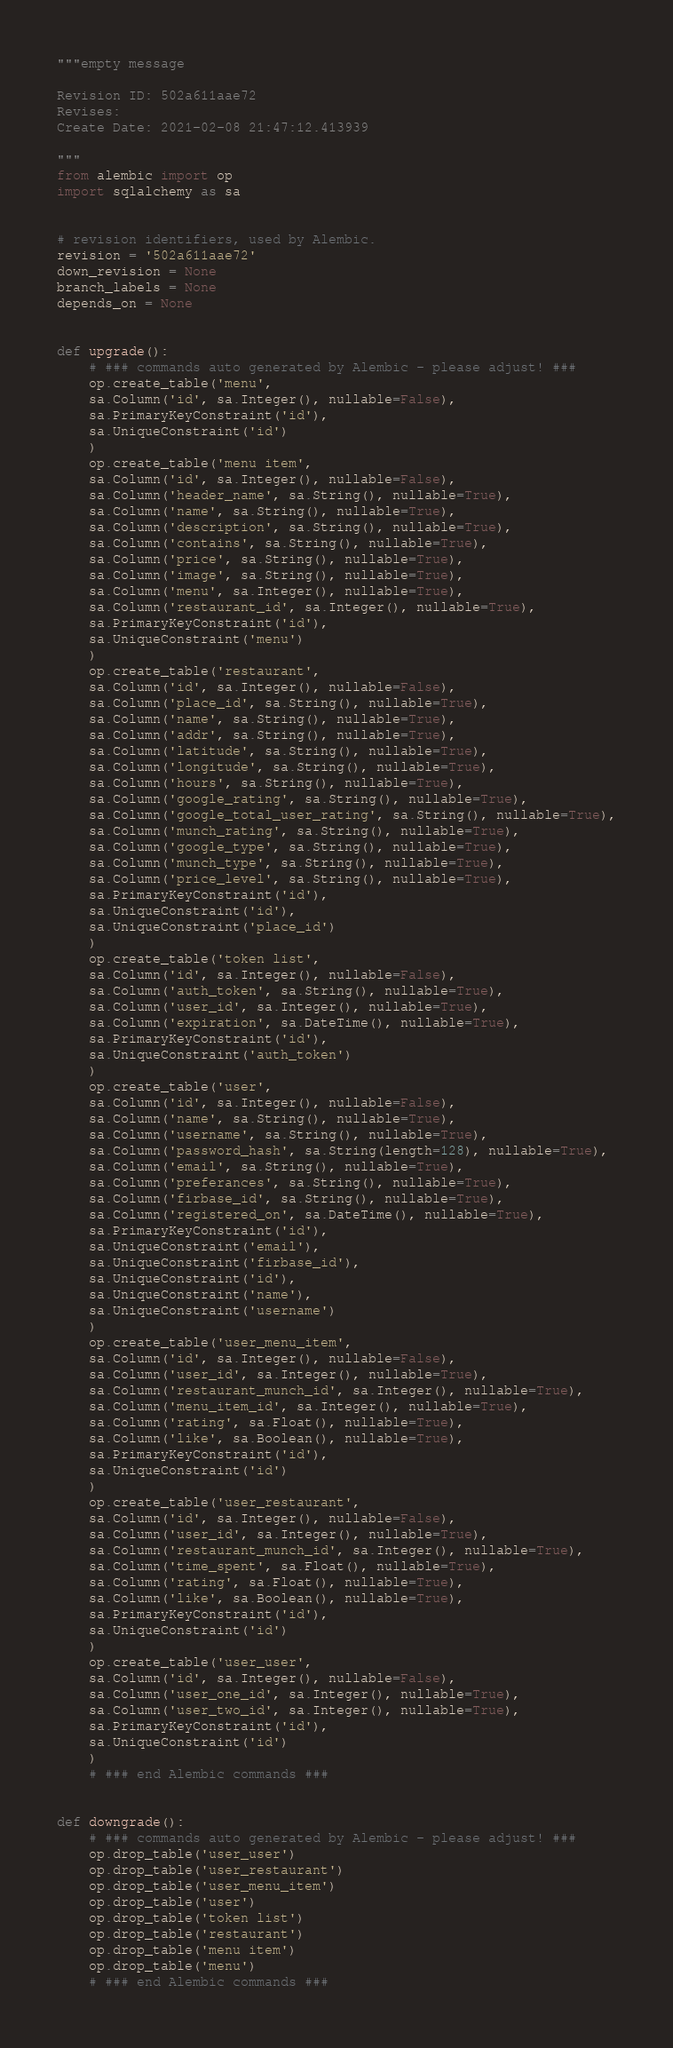<code> <loc_0><loc_0><loc_500><loc_500><_Python_>"""empty message

Revision ID: 502a611aae72
Revises: 
Create Date: 2021-02-08 21:47:12.413939

"""
from alembic import op
import sqlalchemy as sa


# revision identifiers, used by Alembic.
revision = '502a611aae72'
down_revision = None
branch_labels = None
depends_on = None


def upgrade():
    # ### commands auto generated by Alembic - please adjust! ###
    op.create_table('menu',
    sa.Column('id', sa.Integer(), nullable=False),
    sa.PrimaryKeyConstraint('id'),
    sa.UniqueConstraint('id')
    )
    op.create_table('menu item',
    sa.Column('id', sa.Integer(), nullable=False),
    sa.Column('header_name', sa.String(), nullable=True),
    sa.Column('name', sa.String(), nullable=True),
    sa.Column('description', sa.String(), nullable=True),
    sa.Column('contains', sa.String(), nullable=True),
    sa.Column('price', sa.String(), nullable=True),
    sa.Column('image', sa.String(), nullable=True),
    sa.Column('menu', sa.Integer(), nullable=True),
    sa.Column('restaurant_id', sa.Integer(), nullable=True),
    sa.PrimaryKeyConstraint('id'),
    sa.UniqueConstraint('menu')
    )
    op.create_table('restaurant',
    sa.Column('id', sa.Integer(), nullable=False),
    sa.Column('place_id', sa.String(), nullable=True),
    sa.Column('name', sa.String(), nullable=True),
    sa.Column('addr', sa.String(), nullable=True),
    sa.Column('latitude', sa.String(), nullable=True),
    sa.Column('longitude', sa.String(), nullable=True),
    sa.Column('hours', sa.String(), nullable=True),
    sa.Column('google_rating', sa.String(), nullable=True),
    sa.Column('google_total_user_rating', sa.String(), nullable=True),
    sa.Column('munch_rating', sa.String(), nullable=True),
    sa.Column('google_type', sa.String(), nullable=True),
    sa.Column('munch_type', sa.String(), nullable=True),
    sa.Column('price_level', sa.String(), nullable=True),
    sa.PrimaryKeyConstraint('id'),
    sa.UniqueConstraint('id'),
    sa.UniqueConstraint('place_id')
    )
    op.create_table('token list',
    sa.Column('id', sa.Integer(), nullable=False),
    sa.Column('auth_token', sa.String(), nullable=True),
    sa.Column('user_id', sa.Integer(), nullable=True),
    sa.Column('expiration', sa.DateTime(), nullable=True),
    sa.PrimaryKeyConstraint('id'),
    sa.UniqueConstraint('auth_token')
    )
    op.create_table('user',
    sa.Column('id', sa.Integer(), nullable=False),
    sa.Column('name', sa.String(), nullable=True),
    sa.Column('username', sa.String(), nullable=True),
    sa.Column('password_hash', sa.String(length=128), nullable=True),
    sa.Column('email', sa.String(), nullable=True),
    sa.Column('preferances', sa.String(), nullable=True),
    sa.Column('firbase_id', sa.String(), nullable=True),
    sa.Column('registered_on', sa.DateTime(), nullable=True),
    sa.PrimaryKeyConstraint('id'),
    sa.UniqueConstraint('email'),
    sa.UniqueConstraint('firbase_id'),
    sa.UniqueConstraint('id'),
    sa.UniqueConstraint('name'),
    sa.UniqueConstraint('username')
    )
    op.create_table('user_menu_item',
    sa.Column('id', sa.Integer(), nullable=False),
    sa.Column('user_id', sa.Integer(), nullable=True),
    sa.Column('restaurant_munch_id', sa.Integer(), nullable=True),
    sa.Column('menu_item_id', sa.Integer(), nullable=True),
    sa.Column('rating', sa.Float(), nullable=True),
    sa.Column('like', sa.Boolean(), nullable=True),
    sa.PrimaryKeyConstraint('id'),
    sa.UniqueConstraint('id')
    )
    op.create_table('user_restaurant',
    sa.Column('id', sa.Integer(), nullable=False),
    sa.Column('user_id', sa.Integer(), nullable=True),
    sa.Column('restaurant_munch_id', sa.Integer(), nullable=True),
    sa.Column('time_spent', sa.Float(), nullable=True),
    sa.Column('rating', sa.Float(), nullable=True),
    sa.Column('like', sa.Boolean(), nullable=True),
    sa.PrimaryKeyConstraint('id'),
    sa.UniqueConstraint('id')
    )
    op.create_table('user_user',
    sa.Column('id', sa.Integer(), nullable=False),
    sa.Column('user_one_id', sa.Integer(), nullable=True),
    sa.Column('user_two_id', sa.Integer(), nullable=True),
    sa.PrimaryKeyConstraint('id'),
    sa.UniqueConstraint('id')
    )
    # ### end Alembic commands ###


def downgrade():
    # ### commands auto generated by Alembic - please adjust! ###
    op.drop_table('user_user')
    op.drop_table('user_restaurant')
    op.drop_table('user_menu_item')
    op.drop_table('user')
    op.drop_table('token list')
    op.drop_table('restaurant')
    op.drop_table('menu item')
    op.drop_table('menu')
    # ### end Alembic commands ###
</code> 